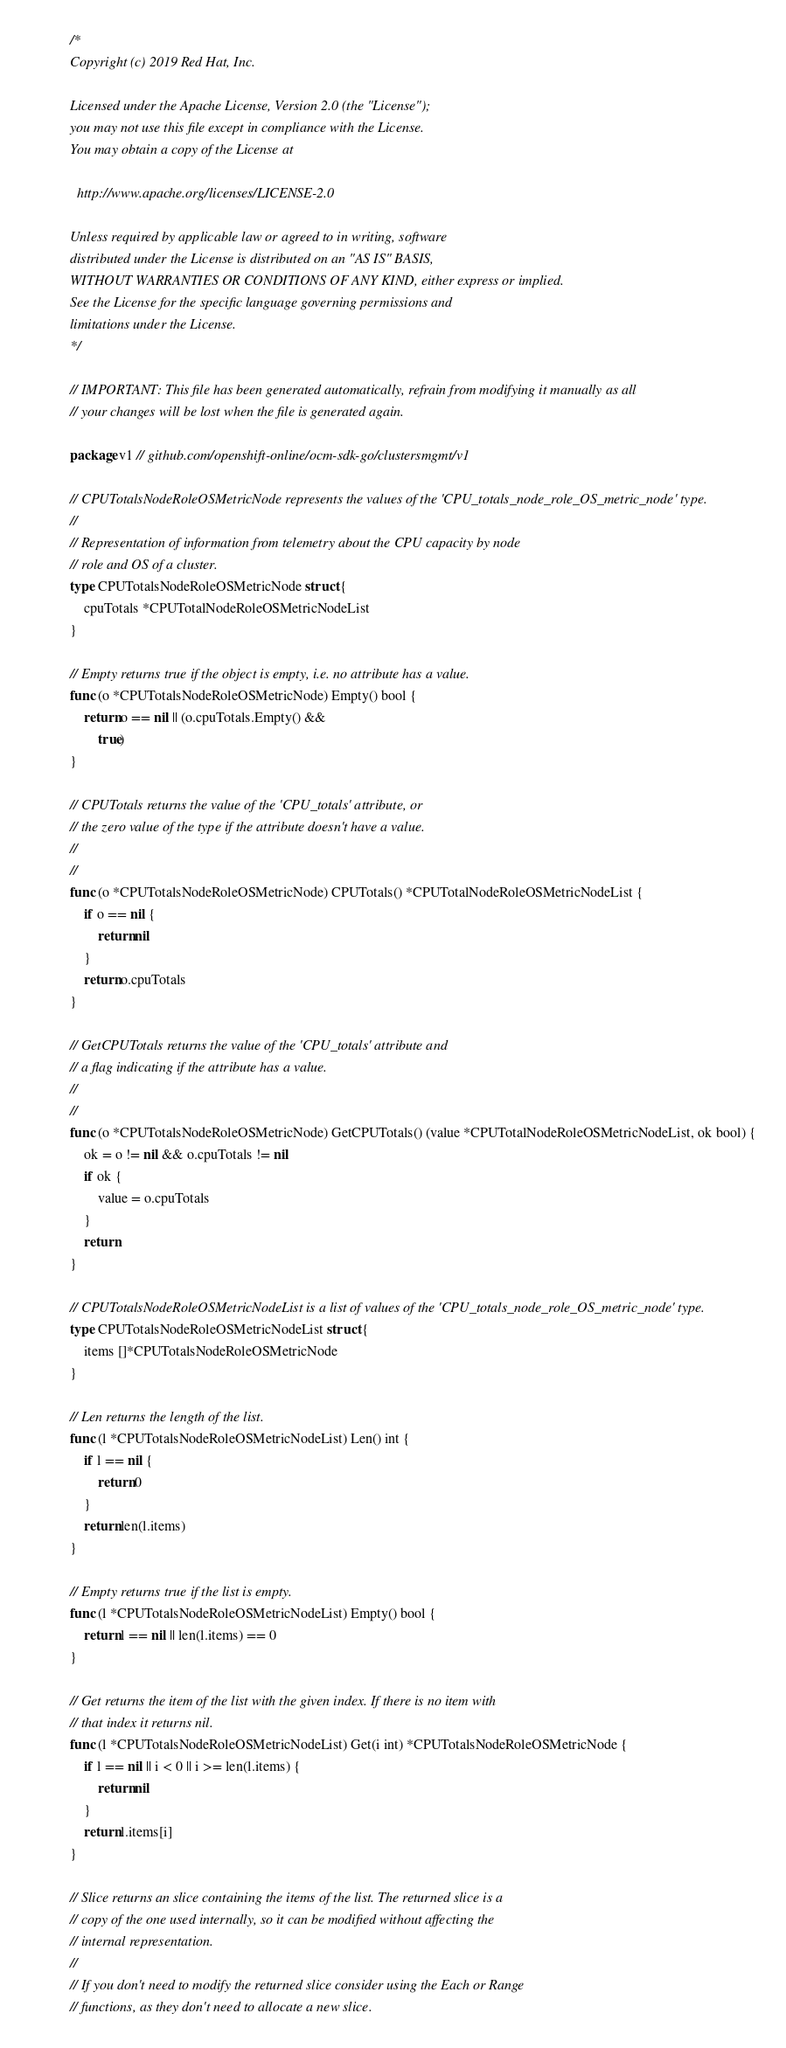Convert code to text. <code><loc_0><loc_0><loc_500><loc_500><_Go_>/*
Copyright (c) 2019 Red Hat, Inc.

Licensed under the Apache License, Version 2.0 (the "License");
you may not use this file except in compliance with the License.
You may obtain a copy of the License at

  http://www.apache.org/licenses/LICENSE-2.0

Unless required by applicable law or agreed to in writing, software
distributed under the License is distributed on an "AS IS" BASIS,
WITHOUT WARRANTIES OR CONDITIONS OF ANY KIND, either express or implied.
See the License for the specific language governing permissions and
limitations under the License.
*/

// IMPORTANT: This file has been generated automatically, refrain from modifying it manually as all
// your changes will be lost when the file is generated again.

package v1 // github.com/openshift-online/ocm-sdk-go/clustersmgmt/v1

// CPUTotalsNodeRoleOSMetricNode represents the values of the 'CPU_totals_node_role_OS_metric_node' type.
//
// Representation of information from telemetry about the CPU capacity by node
// role and OS of a cluster.
type CPUTotalsNodeRoleOSMetricNode struct {
	cpuTotals *CPUTotalNodeRoleOSMetricNodeList
}

// Empty returns true if the object is empty, i.e. no attribute has a value.
func (o *CPUTotalsNodeRoleOSMetricNode) Empty() bool {
	return o == nil || (o.cpuTotals.Empty() &&
		true)
}

// CPUTotals returns the value of the 'CPU_totals' attribute, or
// the zero value of the type if the attribute doesn't have a value.
//
//
func (o *CPUTotalsNodeRoleOSMetricNode) CPUTotals() *CPUTotalNodeRoleOSMetricNodeList {
	if o == nil {
		return nil
	}
	return o.cpuTotals
}

// GetCPUTotals returns the value of the 'CPU_totals' attribute and
// a flag indicating if the attribute has a value.
//
//
func (o *CPUTotalsNodeRoleOSMetricNode) GetCPUTotals() (value *CPUTotalNodeRoleOSMetricNodeList, ok bool) {
	ok = o != nil && o.cpuTotals != nil
	if ok {
		value = o.cpuTotals
	}
	return
}

// CPUTotalsNodeRoleOSMetricNodeList is a list of values of the 'CPU_totals_node_role_OS_metric_node' type.
type CPUTotalsNodeRoleOSMetricNodeList struct {
	items []*CPUTotalsNodeRoleOSMetricNode
}

// Len returns the length of the list.
func (l *CPUTotalsNodeRoleOSMetricNodeList) Len() int {
	if l == nil {
		return 0
	}
	return len(l.items)
}

// Empty returns true if the list is empty.
func (l *CPUTotalsNodeRoleOSMetricNodeList) Empty() bool {
	return l == nil || len(l.items) == 0
}

// Get returns the item of the list with the given index. If there is no item with
// that index it returns nil.
func (l *CPUTotalsNodeRoleOSMetricNodeList) Get(i int) *CPUTotalsNodeRoleOSMetricNode {
	if l == nil || i < 0 || i >= len(l.items) {
		return nil
	}
	return l.items[i]
}

// Slice returns an slice containing the items of the list. The returned slice is a
// copy of the one used internally, so it can be modified without affecting the
// internal representation.
//
// If you don't need to modify the returned slice consider using the Each or Range
// functions, as they don't need to allocate a new slice.</code> 